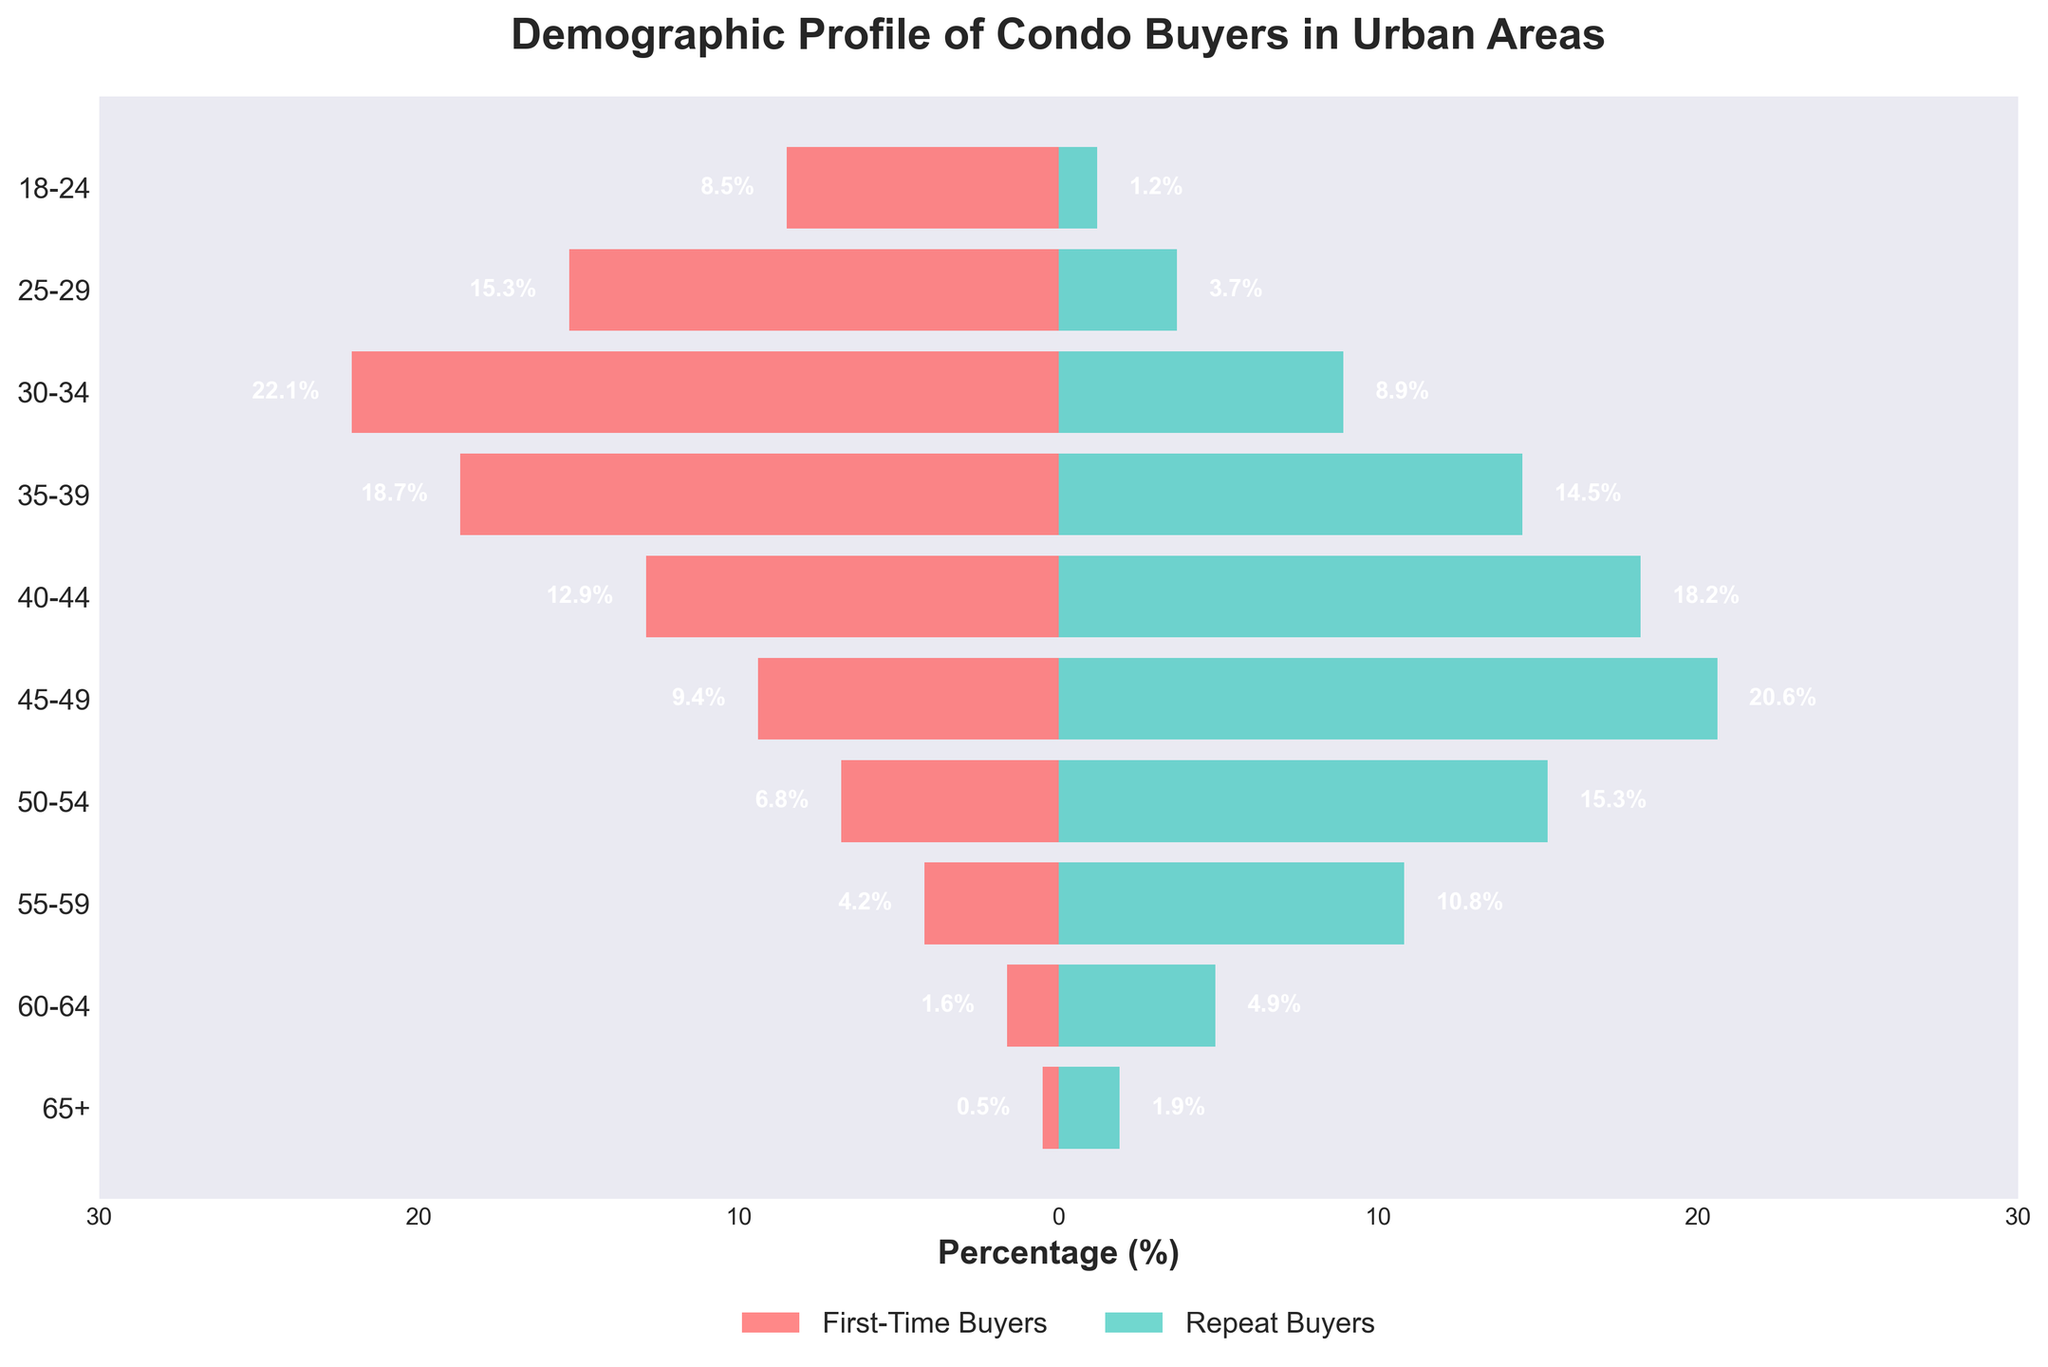What is the title of the figure? The title of the figure is prominently displayed at the top. It reads "Demographic Profile of Condo Buyers in Urban Areas".
Answer: Demographic Profile of Condo Buyers in Urban Areas Which age group has the highest percentage of first-time buyers? We look at the left side of the pyramid where the bars for first-time buyers are located. The longest bar corresponds to the age group 30-34.
Answer: 30-34 Which age group has the lowest percentage of repeat buyers? On the right side of the pyramid, the shortest bar represents the age group with the smallest percentage of repeat buyers. This is the 18-24 age group.
Answer: 18-24 How many age groups have a percentage of first-time buyers greater than 10%? We count the number of bars on the left side of the pyramid that extend beyond the 10% mark. These bars correspond to the age groups: 18-24, 25-29, 30-34, 35-39, and 40-44.
Answer: 5 What is the range of percentages for repeat buyers in the 50-54 age group? For the age group 50-54, the bar on the right side stops at 15.3%, so the range is 0% to 15.3%.
Answer: 0% to 15.3% Compare the percentage of first-time buyers in the 35-39 age group with the percentage of repeat buyers in the same age group. Which is higher? We look at both sides of the pyramid for the age group 35-39. The first-time buyers have a percentage of 18.7% and the repeat buyers have 14.5%. The percentage of first-time buyers is higher.
Answer: First-time buyers Within the age group 45-49, what is the difference in percentage between repeat buyers and first-time buyers? The repeat buyers in the age group 45-49 have a percentage of 20.6%, and the first-time buyers have a percentage of 9.4%. The difference is 20.6% - 9.4%.
Answer: 11.2% Which age group shows the most balanced percentages of first-time and repeat buyers? We need to identify the age group where the lengths of the bars for first-time buyers and repeat buyers are closest to each other. For the age group 35-39, the first-time buyers are at 18.7% and repeat buyers are at 14.5%, showing the smallest difference among all groups.
Answer: 35-39 Calculate the total percentage of first-time buyers for the age groups 18-24 and 25-29. We sum the percentages of first-time buyers for the 18-24 (8.5%) and 25-29 (15.3%) age groups. 8.5 + 15.3 = 23.8.
Answer: 23.8% Describe the general trend for first-time buyers as age increases. By examining the left side of the pyramid, we observe that the percentage of first-time buyers decreases as the age groups increase. The percentage starts high in the younger age groups and gradually decreases towards the older age groups.
Answer: Decreasing 